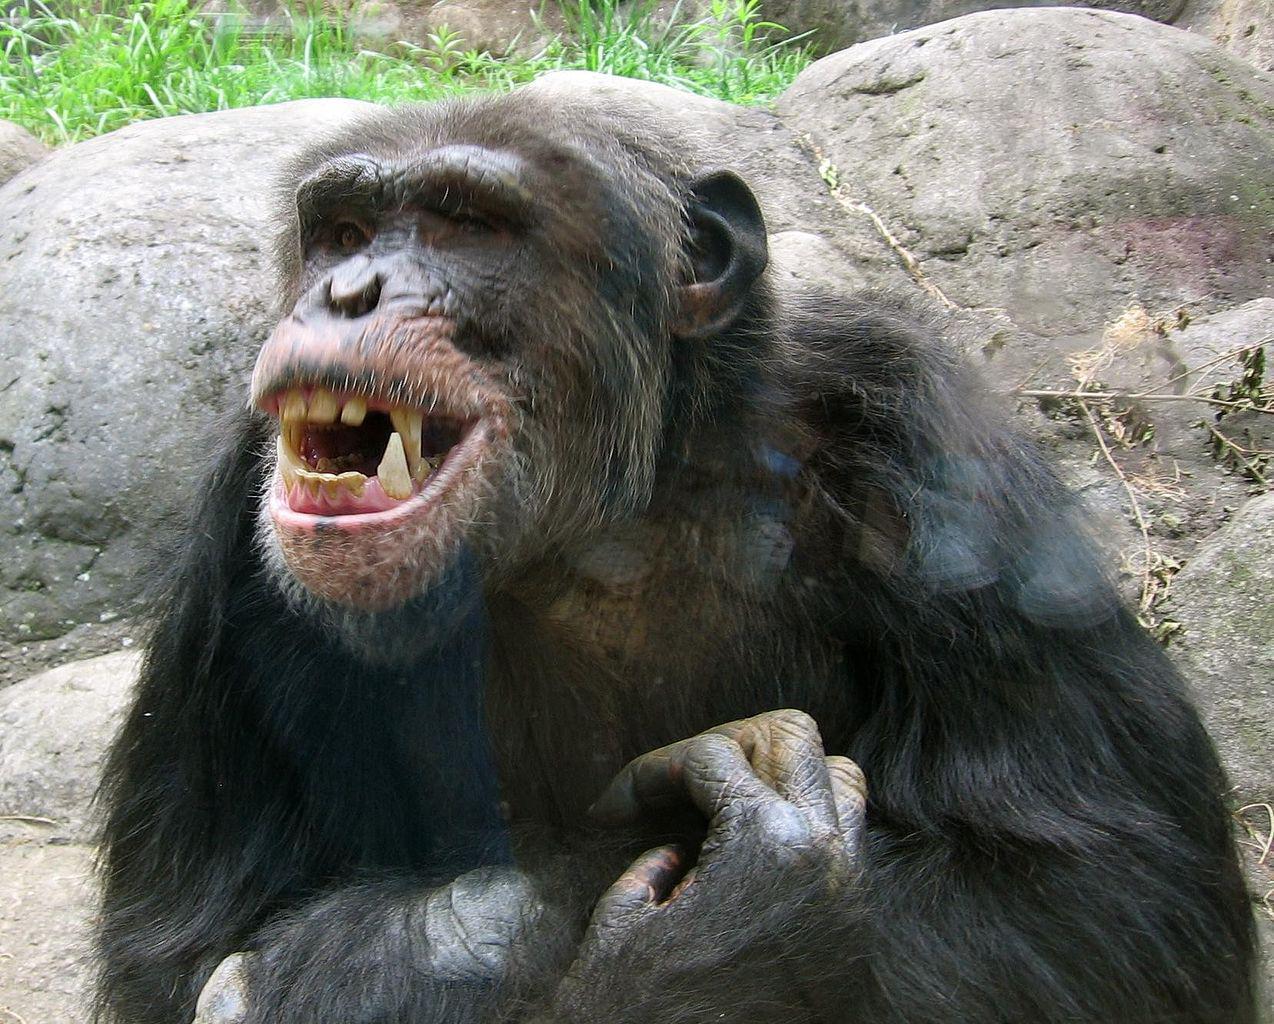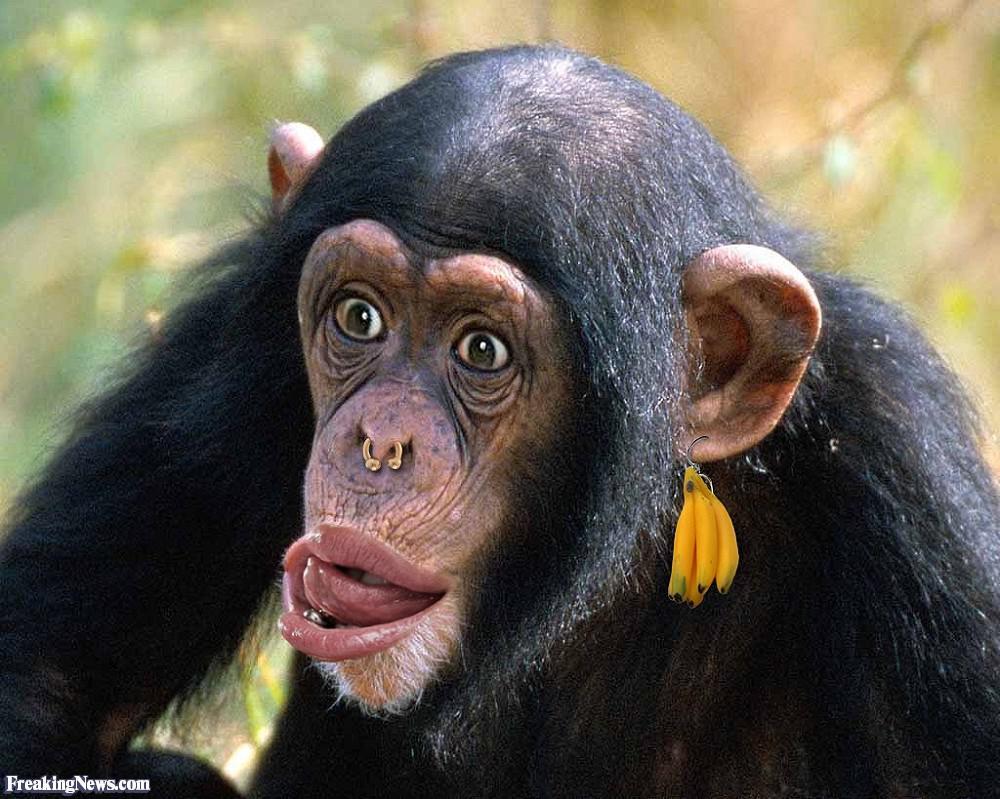The first image is the image on the left, the second image is the image on the right. For the images displayed, is the sentence "At least one primate is sticking their tongue out." factually correct? Answer yes or no. Yes. The first image is the image on the left, the second image is the image on the right. For the images displayed, is the sentence "A small monkey with non-black fur scratches its head, in one image." factually correct? Answer yes or no. No. 